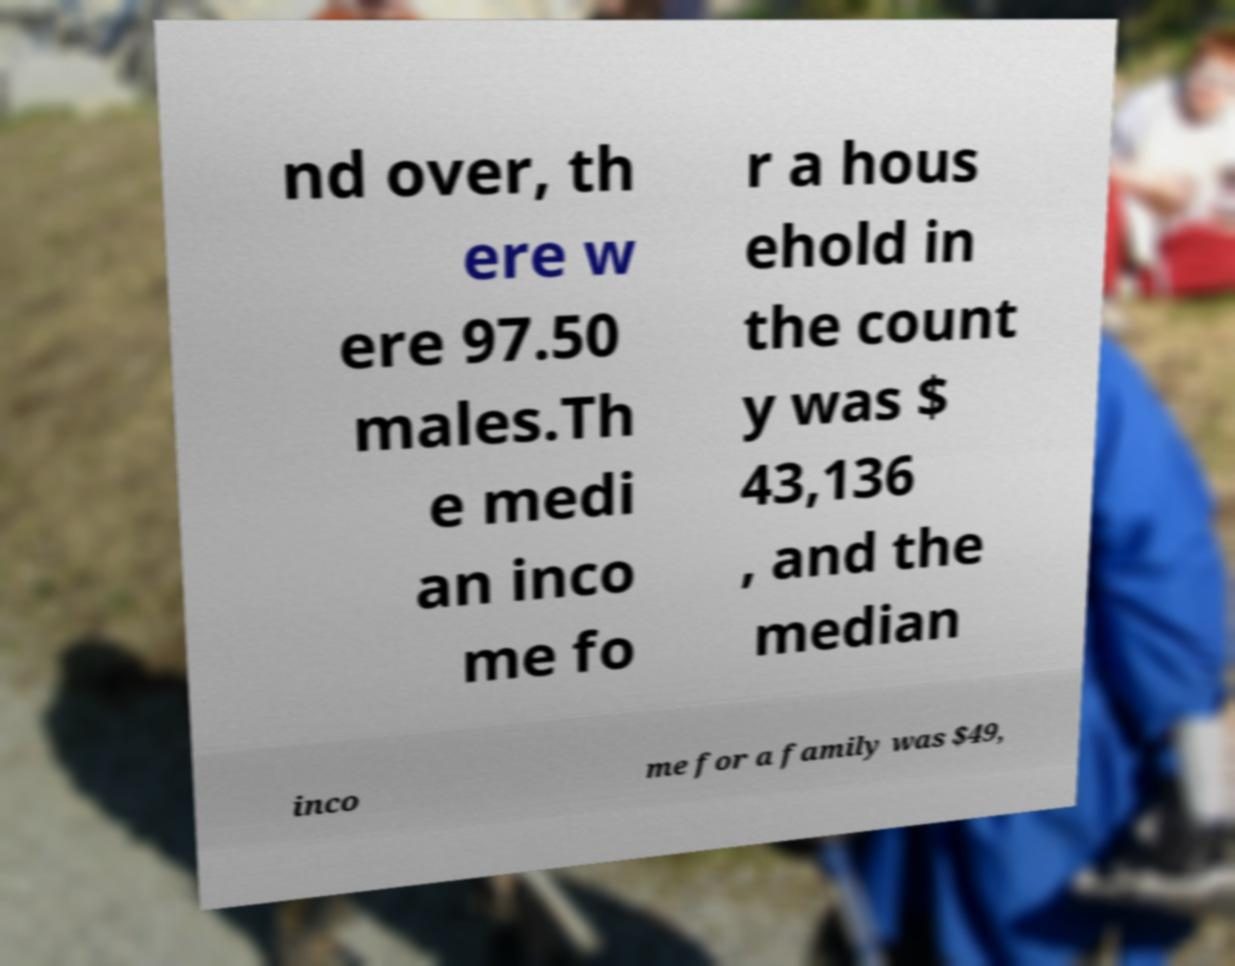Can you accurately transcribe the text from the provided image for me? nd over, th ere w ere 97.50 males.Th e medi an inco me fo r a hous ehold in the count y was $ 43,136 , and the median inco me for a family was $49, 